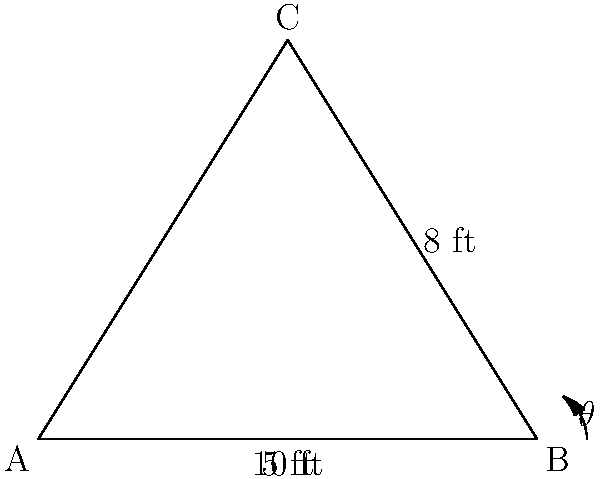During practice, you're teaching your team about the optimal arc for shooting. A player releases the ball 5 feet from the basket, which is 10 feet high. If the ball reaches its maximum height 8 feet above the ground directly above the release point, what is the angle θ (in degrees) at which the ball should be launched for this trajectory? Round your answer to the nearest degree. Let's approach this step-by-step:

1) First, we need to identify the right triangle formed by the ball's trajectory. In this case, we have:
   - The adjacent side (horizontal distance) = 5 feet
   - The opposite side (vertical distance) = 8 feet

2) We're looking for the angle θ, which is formed at the point where the ball is released.

3) To find this angle, we can use the arctangent function (tan⁻¹ or atan), which gives us the angle when we know the opposite and adjacent sides.

4) The formula is:
   $$\theta = \tan^{-1}\left(\frac{\text{opposite}}{\text{adjacent}}\right)$$

5) Plugging in our values:
   $$\theta = \tan^{-1}\left(\frac{8}{5}\right)$$

6) Using a calculator or computer:
   $$\theta \approx 58.0°$$

7) Rounding to the nearest degree:
   $$\theta = 58°$$

This angle represents the optimal launch angle for the given trajectory, assuming no air resistance and ideal conditions.
Answer: 58° 